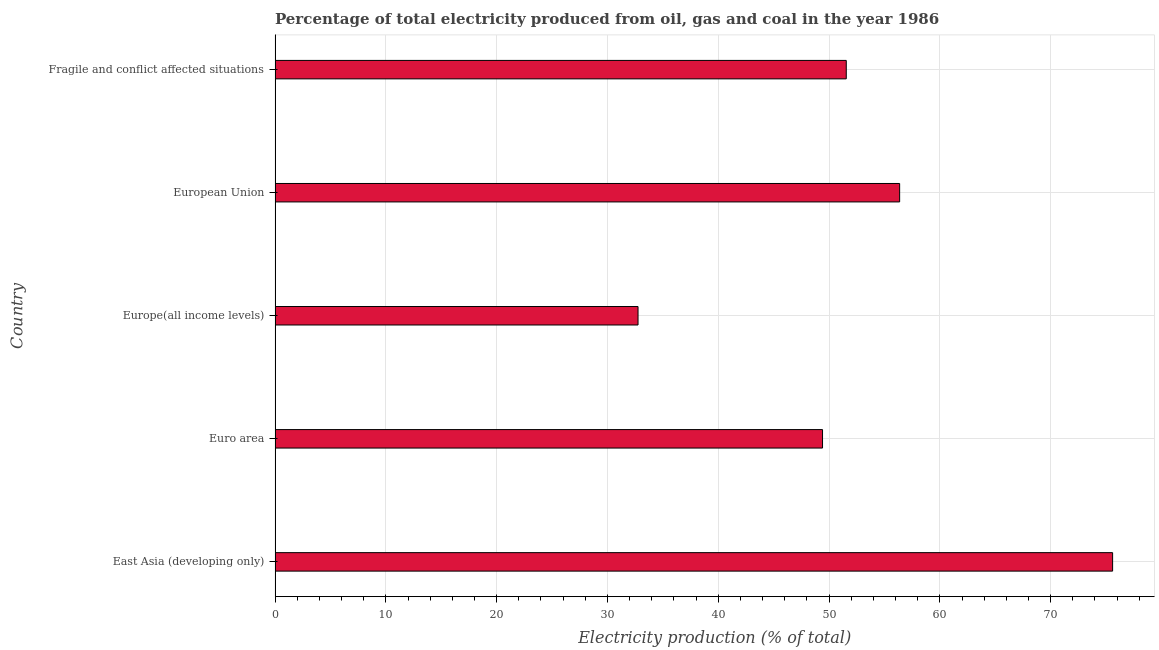Does the graph contain any zero values?
Give a very brief answer. No. What is the title of the graph?
Provide a short and direct response. Percentage of total electricity produced from oil, gas and coal in the year 1986. What is the label or title of the X-axis?
Keep it short and to the point. Electricity production (% of total). What is the label or title of the Y-axis?
Make the answer very short. Country. What is the electricity production in Fragile and conflict affected situations?
Provide a short and direct response. 51.55. Across all countries, what is the maximum electricity production?
Offer a terse response. 75.59. Across all countries, what is the minimum electricity production?
Keep it short and to the point. 32.76. In which country was the electricity production maximum?
Make the answer very short. East Asia (developing only). In which country was the electricity production minimum?
Offer a terse response. Europe(all income levels). What is the sum of the electricity production?
Provide a short and direct response. 265.69. What is the difference between the electricity production in European Union and Fragile and conflict affected situations?
Ensure brevity in your answer.  4.82. What is the average electricity production per country?
Your response must be concise. 53.14. What is the median electricity production?
Ensure brevity in your answer.  51.55. What is the ratio of the electricity production in East Asia (developing only) to that in Europe(all income levels)?
Your answer should be very brief. 2.31. What is the difference between the highest and the second highest electricity production?
Your response must be concise. 19.22. Is the sum of the electricity production in East Asia (developing only) and Euro area greater than the maximum electricity production across all countries?
Offer a very short reply. Yes. What is the difference between the highest and the lowest electricity production?
Offer a very short reply. 42.84. How many bars are there?
Make the answer very short. 5. How many countries are there in the graph?
Offer a terse response. 5. What is the Electricity production (% of total) of East Asia (developing only)?
Offer a terse response. 75.59. What is the Electricity production (% of total) of Euro area?
Your answer should be very brief. 49.41. What is the Electricity production (% of total) in Europe(all income levels)?
Your answer should be very brief. 32.76. What is the Electricity production (% of total) in European Union?
Ensure brevity in your answer.  56.37. What is the Electricity production (% of total) of Fragile and conflict affected situations?
Provide a short and direct response. 51.55. What is the difference between the Electricity production (% of total) in East Asia (developing only) and Euro area?
Provide a short and direct response. 26.18. What is the difference between the Electricity production (% of total) in East Asia (developing only) and Europe(all income levels)?
Provide a succinct answer. 42.84. What is the difference between the Electricity production (% of total) in East Asia (developing only) and European Union?
Offer a very short reply. 19.22. What is the difference between the Electricity production (% of total) in East Asia (developing only) and Fragile and conflict affected situations?
Provide a short and direct response. 24.04. What is the difference between the Electricity production (% of total) in Euro area and Europe(all income levels)?
Your answer should be compact. 16.65. What is the difference between the Electricity production (% of total) in Euro area and European Union?
Offer a terse response. -6.96. What is the difference between the Electricity production (% of total) in Euro area and Fragile and conflict affected situations?
Keep it short and to the point. -2.14. What is the difference between the Electricity production (% of total) in Europe(all income levels) and European Union?
Provide a succinct answer. -23.61. What is the difference between the Electricity production (% of total) in Europe(all income levels) and Fragile and conflict affected situations?
Keep it short and to the point. -18.79. What is the difference between the Electricity production (% of total) in European Union and Fragile and conflict affected situations?
Keep it short and to the point. 4.82. What is the ratio of the Electricity production (% of total) in East Asia (developing only) to that in Euro area?
Your answer should be very brief. 1.53. What is the ratio of the Electricity production (% of total) in East Asia (developing only) to that in Europe(all income levels)?
Provide a succinct answer. 2.31. What is the ratio of the Electricity production (% of total) in East Asia (developing only) to that in European Union?
Provide a succinct answer. 1.34. What is the ratio of the Electricity production (% of total) in East Asia (developing only) to that in Fragile and conflict affected situations?
Provide a succinct answer. 1.47. What is the ratio of the Electricity production (% of total) in Euro area to that in Europe(all income levels)?
Offer a very short reply. 1.51. What is the ratio of the Electricity production (% of total) in Euro area to that in European Union?
Give a very brief answer. 0.88. What is the ratio of the Electricity production (% of total) in Euro area to that in Fragile and conflict affected situations?
Offer a terse response. 0.96. What is the ratio of the Electricity production (% of total) in Europe(all income levels) to that in European Union?
Your answer should be compact. 0.58. What is the ratio of the Electricity production (% of total) in Europe(all income levels) to that in Fragile and conflict affected situations?
Your answer should be compact. 0.64. What is the ratio of the Electricity production (% of total) in European Union to that in Fragile and conflict affected situations?
Offer a very short reply. 1.09. 